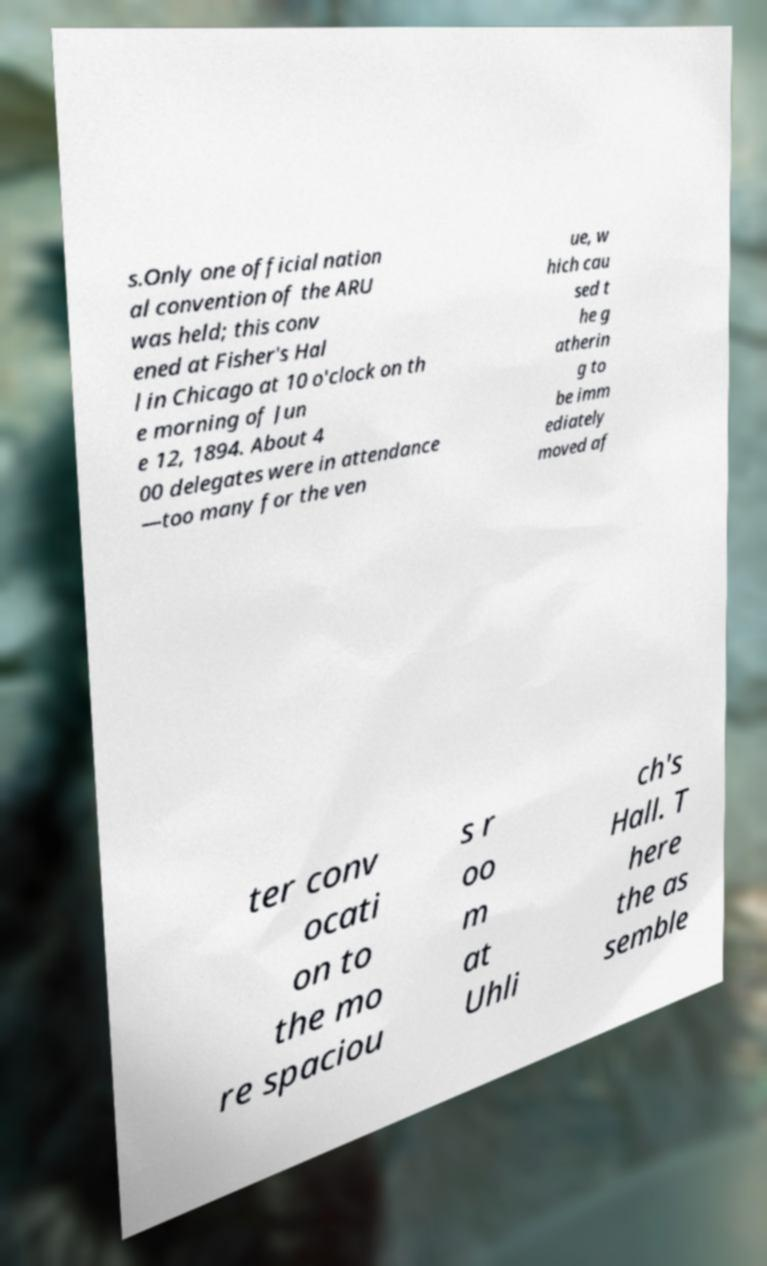There's text embedded in this image that I need extracted. Can you transcribe it verbatim? s.Only one official nation al convention of the ARU was held; this conv ened at Fisher's Hal l in Chicago at 10 o'clock on th e morning of Jun e 12, 1894. About 4 00 delegates were in attendance —too many for the ven ue, w hich cau sed t he g atherin g to be imm ediately moved af ter conv ocati on to the mo re spaciou s r oo m at Uhli ch's Hall. T here the as semble 